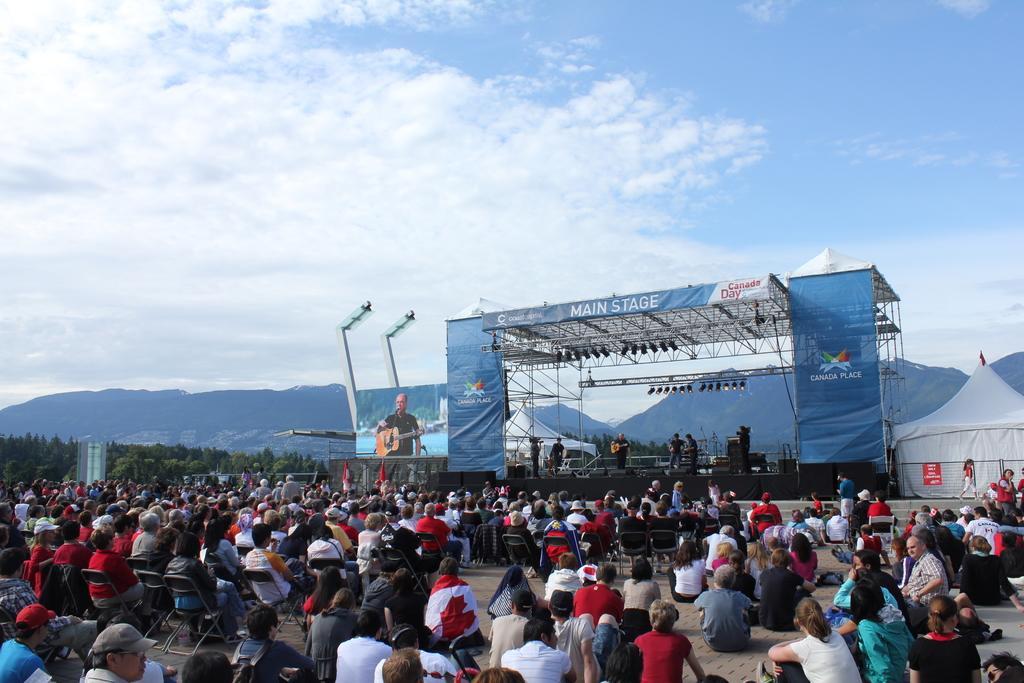Describe this image in one or two sentences. In this image I can see group of people among them some are sitting on chairs and some are sitting on the ground. In the background I can see a stage. On the stage I can see people, banners, stage lights and other objects. I can also see mountains, trees, a tent and the sky. 